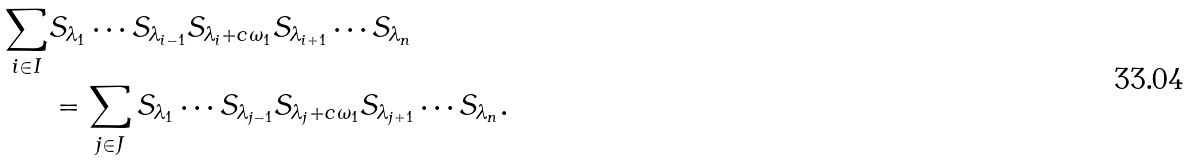Convert formula to latex. <formula><loc_0><loc_0><loc_500><loc_500>\sum _ { i \in I } & S _ { \lambda _ { 1 } } \cdots S _ { \lambda _ { i - 1 } } S _ { \lambda _ { i } + c \omega _ { 1 } } S _ { \lambda _ { i + 1 } } \cdots S _ { \lambda _ { n } } \\ & = \sum _ { j \in J } S _ { \lambda _ { 1 } } \cdots S _ { \lambda _ { j - 1 } } S _ { \lambda _ { j } + c \omega _ { 1 } } S _ { \lambda _ { j + 1 } } \cdots S _ { \lambda _ { n } } .</formula> 